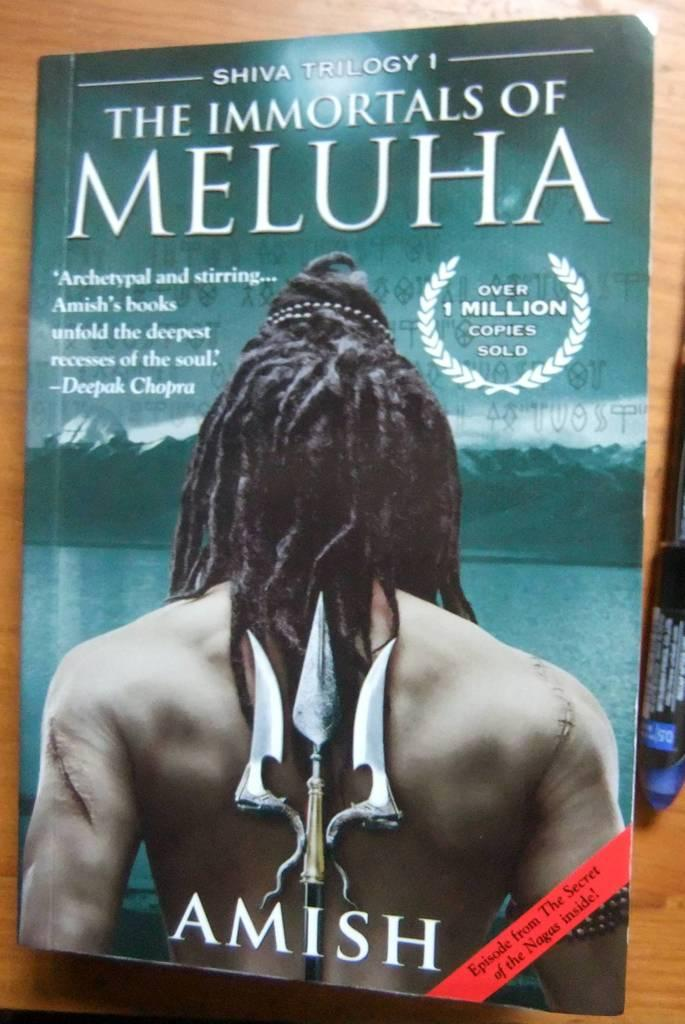<image>
Provide a brief description of the given image. Book cover of one of the Shiva Trilogy with a man in dreads holding a trident behind his back. 